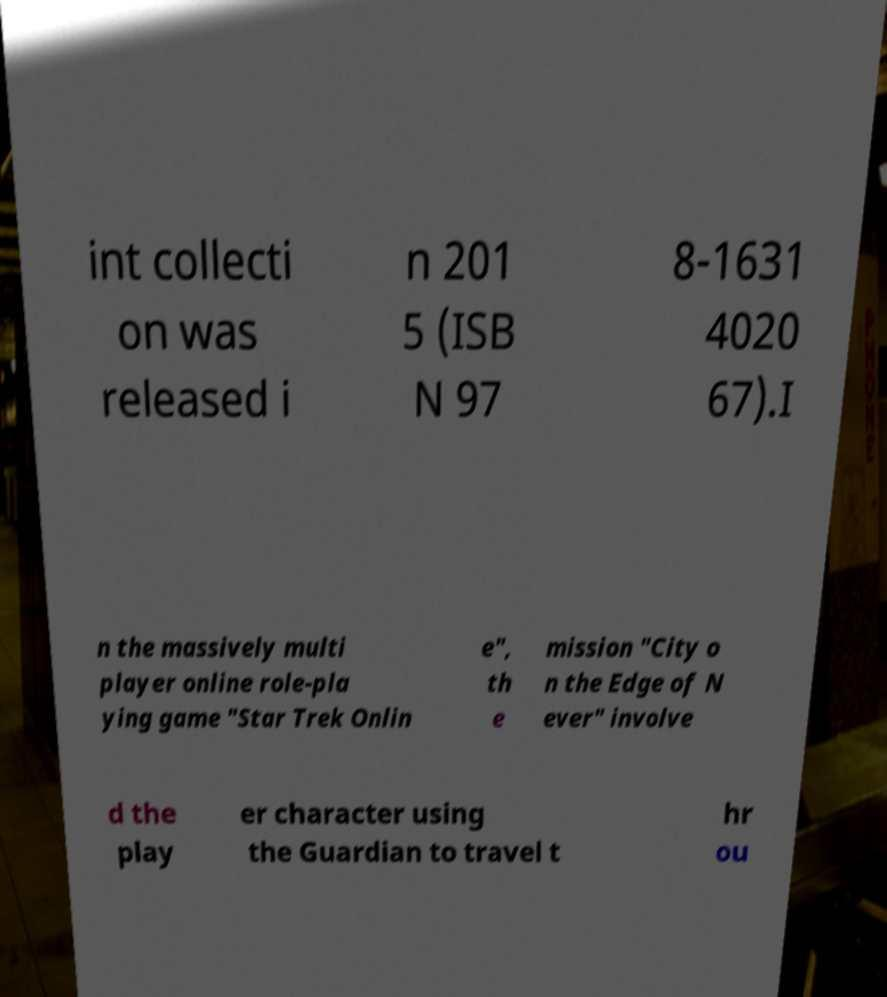For documentation purposes, I need the text within this image transcribed. Could you provide that? int collecti on was released i n 201 5 (ISB N 97 8-1631 4020 67).I n the massively multi player online role-pla ying game "Star Trek Onlin e", th e mission "City o n the Edge of N ever" involve d the play er character using the Guardian to travel t hr ou 